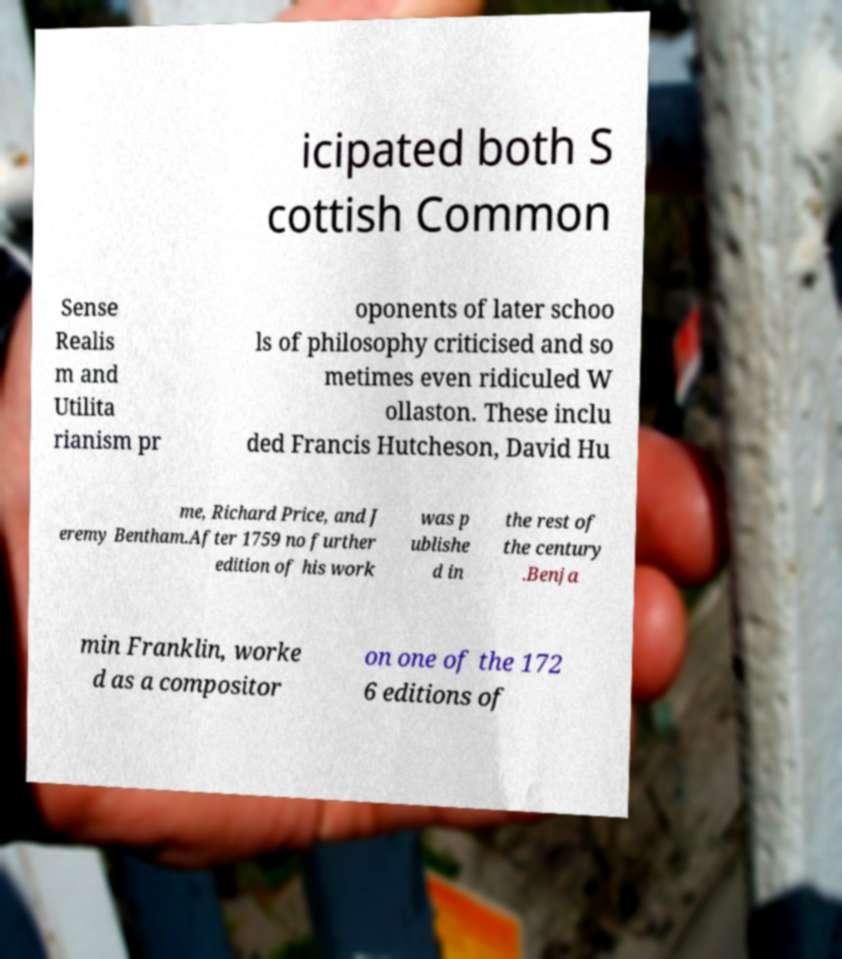Can you accurately transcribe the text from the provided image for me? icipated both S cottish Common Sense Realis m and Utilita rianism pr oponents of later schoo ls of philosophy criticised and so metimes even ridiculed W ollaston. These inclu ded Francis Hutcheson, David Hu me, Richard Price, and J eremy Bentham.After 1759 no further edition of his work was p ublishe d in the rest of the century .Benja min Franklin, worke d as a compositor on one of the 172 6 editions of 